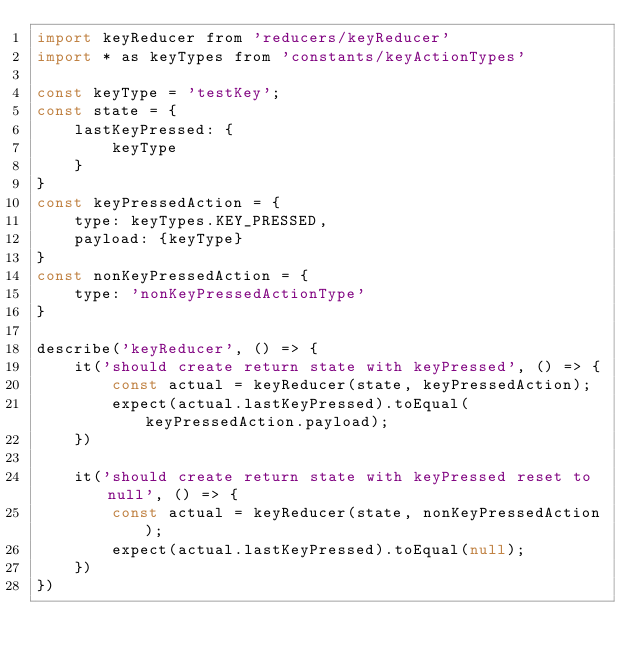Convert code to text. <code><loc_0><loc_0><loc_500><loc_500><_JavaScript_>import keyReducer from 'reducers/keyReducer'
import * as keyTypes from 'constants/keyActionTypes'

const keyType = 'testKey';
const state = {
    lastKeyPressed: {
        keyType
    }
}
const keyPressedAction = {
    type: keyTypes.KEY_PRESSED,
    payload: {keyType}
}
const nonKeyPressedAction = {
    type: 'nonKeyPressedActionType'
}

describe('keyReducer', () => {
    it('should create return state with keyPressed', () => {
        const actual = keyReducer(state, keyPressedAction);
        expect(actual.lastKeyPressed).toEqual(keyPressedAction.payload);
    })

    it('should create return state with keyPressed reset to null', () => {
        const actual = keyReducer(state, nonKeyPressedAction);
        expect(actual.lastKeyPressed).toEqual(null);
    })
})
</code> 